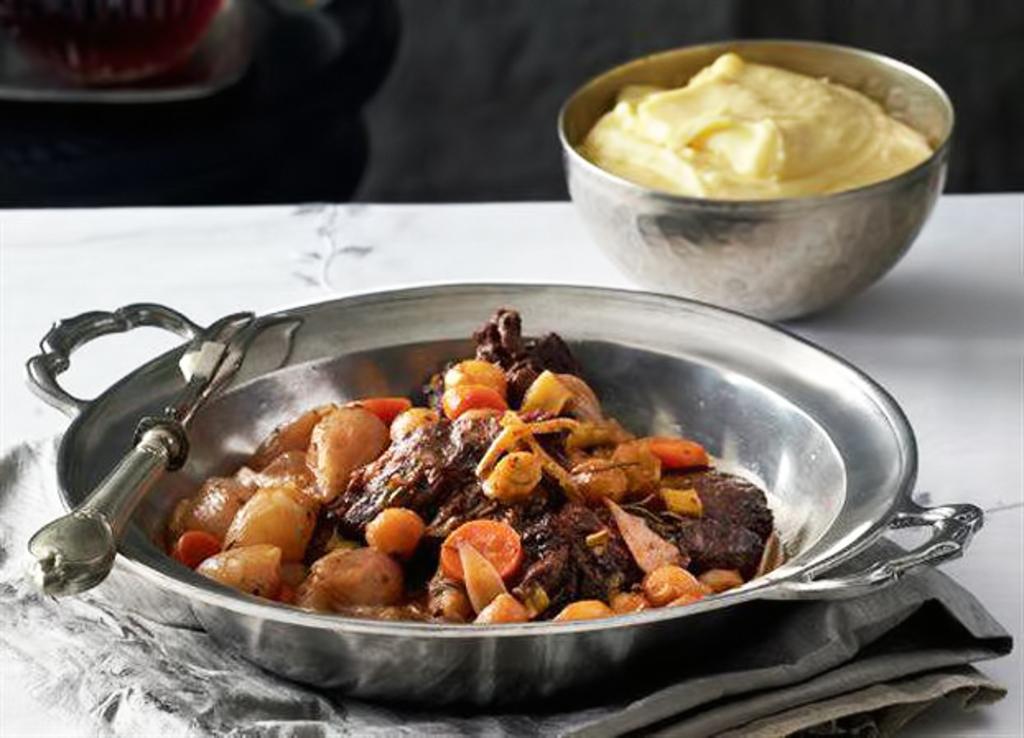How would you summarize this image in a sentence or two? In this picture I can see food items in bowls, there is a fork, there is a cloth on an object, and there is blur background. 